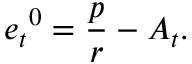Convert formula to latex. <formula><loc_0><loc_0><loc_500><loc_500>{ e _ { t } } ^ { 0 } = \frac { p } { r } - A _ { t } .</formula> 